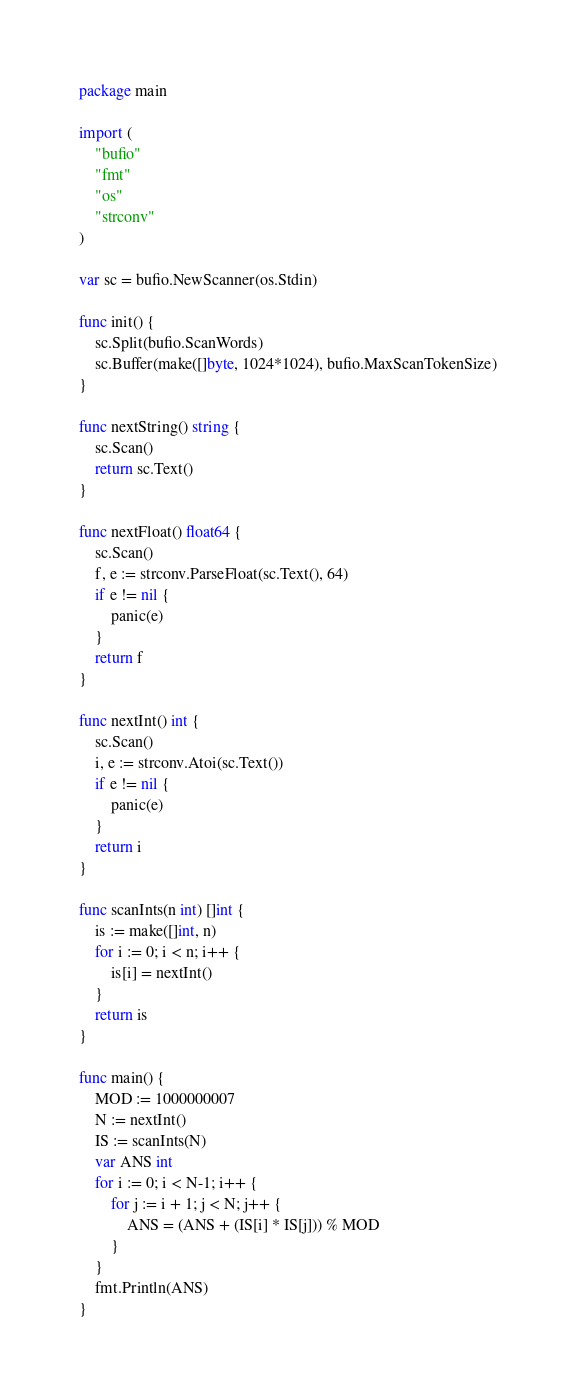<code> <loc_0><loc_0><loc_500><loc_500><_Go_>package main

import (
	"bufio"
	"fmt"
	"os"
	"strconv"
)

var sc = bufio.NewScanner(os.Stdin)

func init() {
	sc.Split(bufio.ScanWords)
	sc.Buffer(make([]byte, 1024*1024), bufio.MaxScanTokenSize)
}

func nextString() string {
	sc.Scan()
	return sc.Text()
}

func nextFloat() float64 {
	sc.Scan()
	f, e := strconv.ParseFloat(sc.Text(), 64)
	if e != nil {
		panic(e)
	}
	return f
}

func nextInt() int {
	sc.Scan()
	i, e := strconv.Atoi(sc.Text())
	if e != nil {
		panic(e)
	}
	return i
}

func scanInts(n int) []int {
	is := make([]int, n)
	for i := 0; i < n; i++ {
		is[i] = nextInt()
	}
	return is
}

func main() {
	MOD := 1000000007
	N := nextInt()
	IS := scanInts(N)
	var ANS int
	for i := 0; i < N-1; i++ {
		for j := i + 1; j < N; j++ {
			ANS = (ANS + (IS[i] * IS[j])) % MOD
		}
	}
	fmt.Println(ANS)
}

</code> 